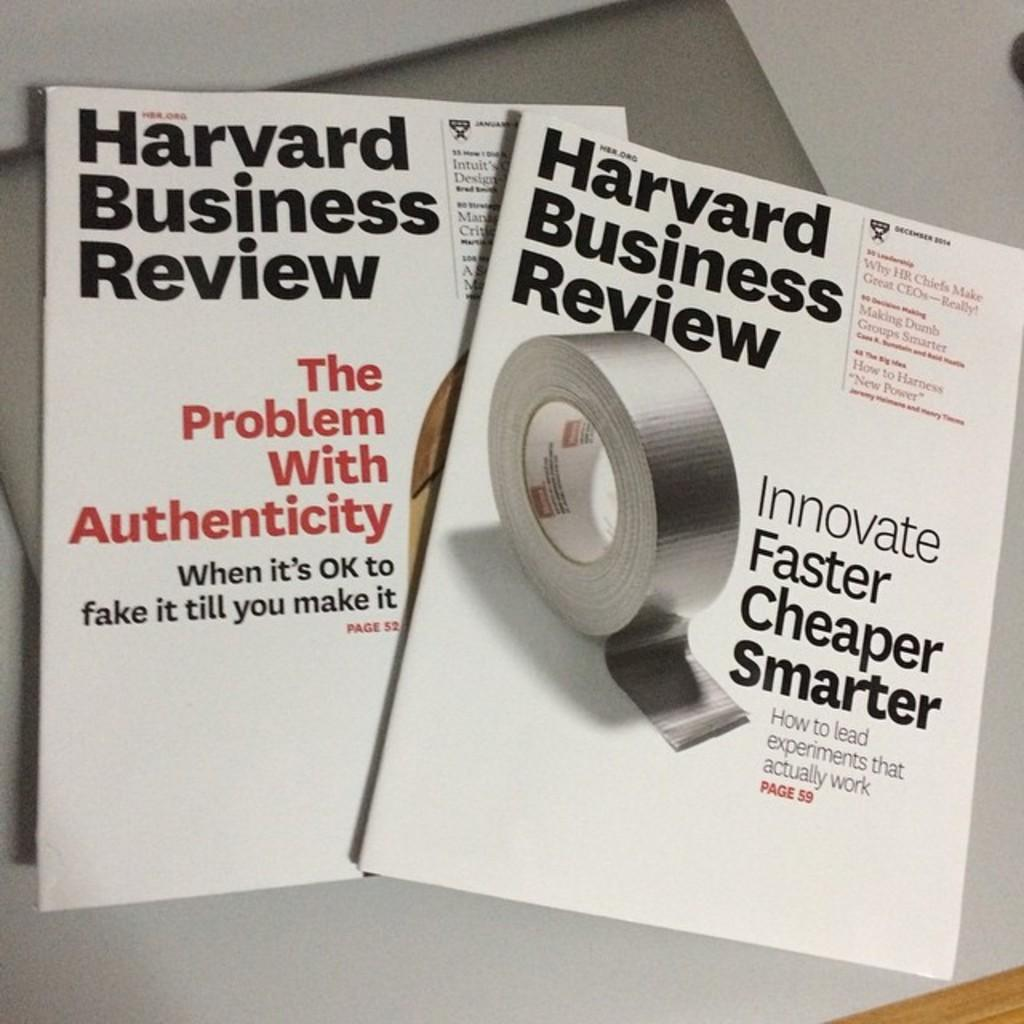<image>
Provide a brief description of the given image. The Harvard Business Review discusses the problem with authenticity. 